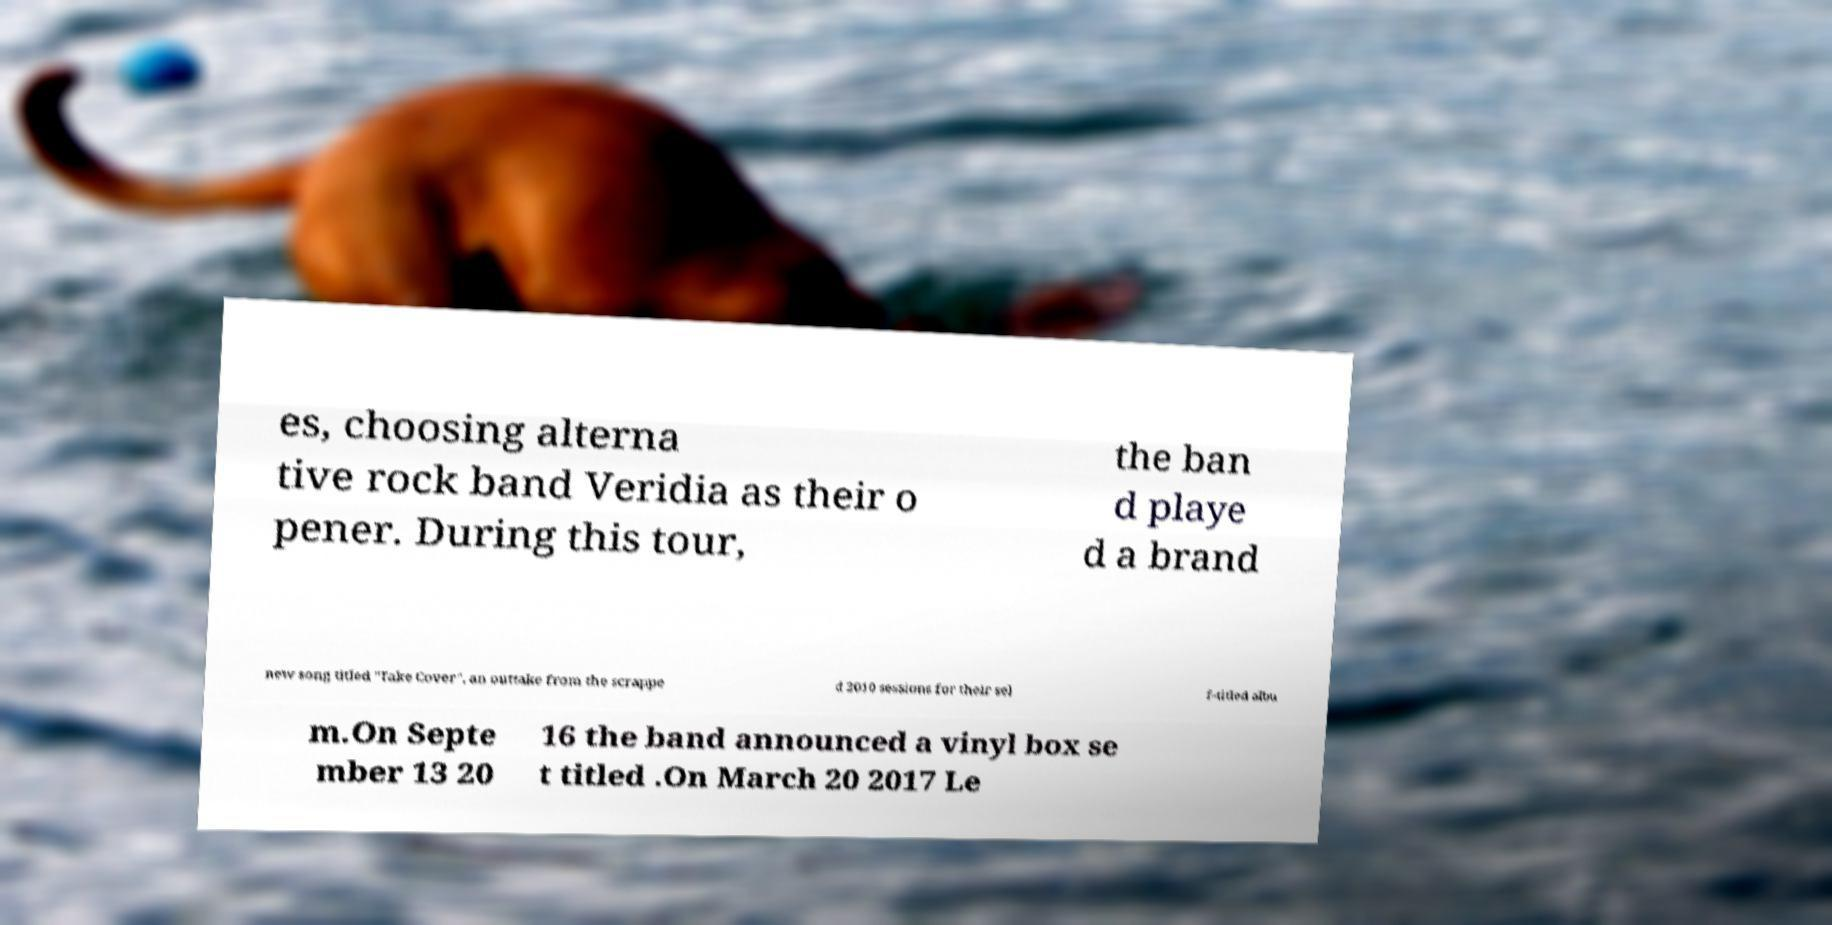Could you extract and type out the text from this image? es, choosing alterna tive rock band Veridia as their o pener. During this tour, the ban d playe d a brand new song titled "Take Cover", an outtake from the scrappe d 2010 sessions for their sel f-titled albu m.On Septe mber 13 20 16 the band announced a vinyl box se t titled .On March 20 2017 Le 